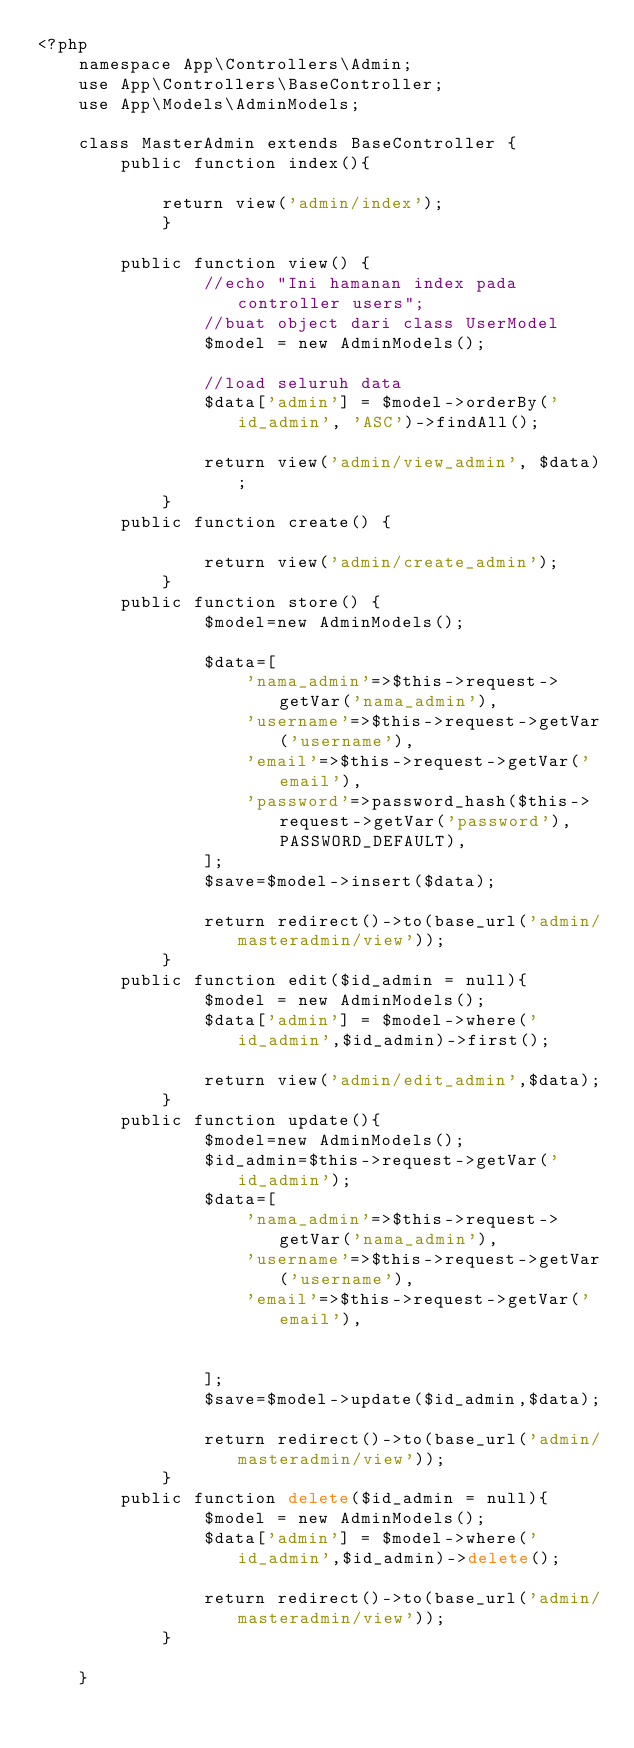Convert code to text. <code><loc_0><loc_0><loc_500><loc_500><_PHP_><?php
    namespace App\Controllers\Admin;
    use App\Controllers\BaseController;
    use App\Models\AdminModels;

    class MasterAdmin extends BaseController {
    	public function index(){
        
            return view('admin/index');
            }
            
        public function view() {
                //echo "Ini hamanan index pada controller users";
                //buat object dari class UserModel
                $model = new AdminModels();
                
                //load seluruh data
                $data['admin'] = $model->orderBy('id_admin', 'ASC')->findAll();
    
                return view('admin/view_admin', $data);
            }
        public function create() {
    
                return view('admin/create_admin');
            }
        public function store() {
                $model=new AdminModels();
    
                $data=[
                    'nama_admin'=>$this->request->getVar('nama_admin'),
                    'username'=>$this->request->getVar('username'),
                    'email'=>$this->request->getVar('email'),
                    'password'=>password_hash($this->request->getVar('password'),PASSWORD_DEFAULT),
                ];
                $save=$model->insert($data);
    
                return redirect()->to(base_url('admin/masteradmin/view'));
            }
        public function edit($id_admin = null){
                $model = new AdminModels();
                $data['admin'] = $model->where('id_admin',$id_admin)->first();
    
                return view('admin/edit_admin',$data);
            }
        public function update(){
                $model=new AdminModels();
                $id_admin=$this->request->getVar('id_admin');
                $data=[
                    'nama_admin'=>$this->request->getVar('nama_admin'),
                    'username'=>$this->request->getVar('username'),
                    'email'=>$this->request->getVar('email'),
               
    
                ];
                $save=$model->update($id_admin,$data);
    
                return redirect()->to(base_url('admin/masteradmin/view'));          
            }
        public function delete($id_admin = null){
                $model = new AdminModels();
                $data['admin'] = $model->where('id_admin',$id_admin)->delete();
    
                return redirect()->to(base_url('admin/masteradmin/view'));
            }

    }</code> 